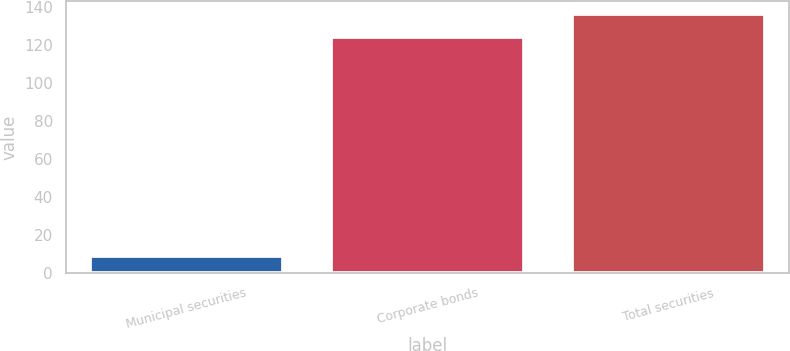Convert chart to OTSL. <chart><loc_0><loc_0><loc_500><loc_500><bar_chart><fcel>Municipal securities<fcel>Corporate bonds<fcel>Total securities<nl><fcel>9<fcel>124<fcel>136.4<nl></chart> 